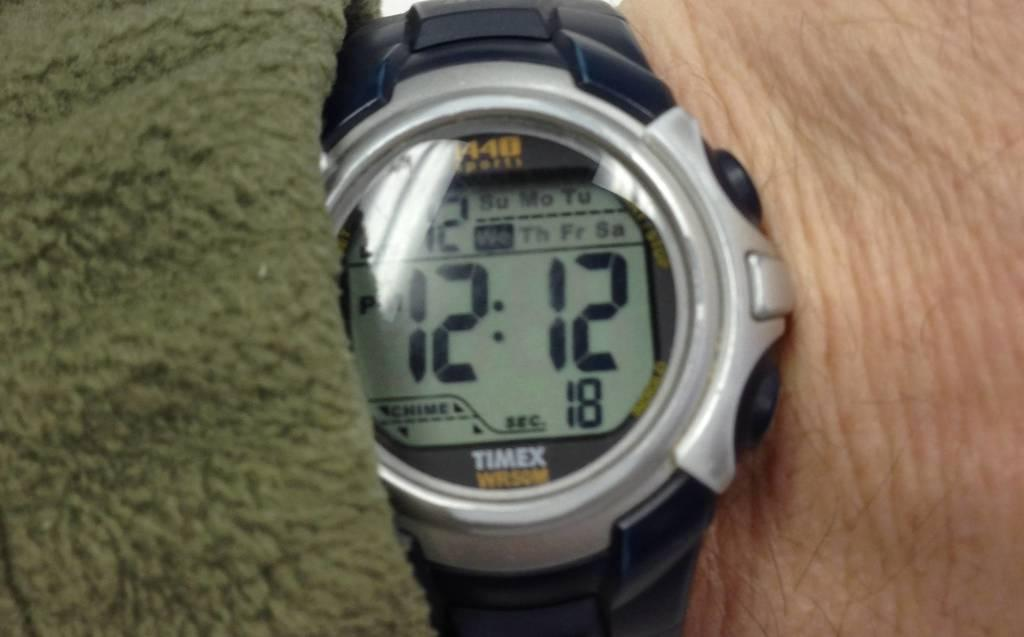<image>
Present a compact description of the photo's key features. A wrist watch with a black band displaying the time of 12:12. 